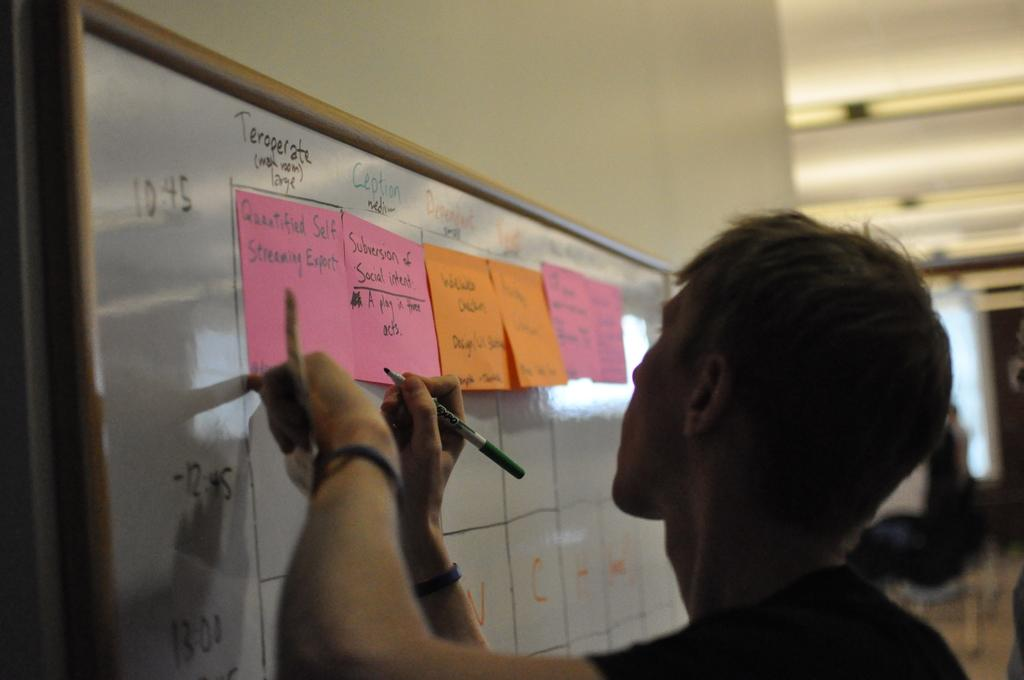<image>
Give a short and clear explanation of the subsequent image. Person writing on a pink note which says "Subversion Social" on it. 